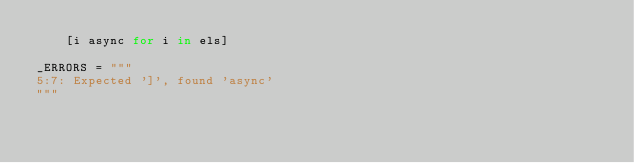<code> <loc_0><loc_0><loc_500><loc_500><_Cython_>    [i async for i in els]

_ERRORS = """
5:7: Expected ']', found 'async'
"""
</code> 